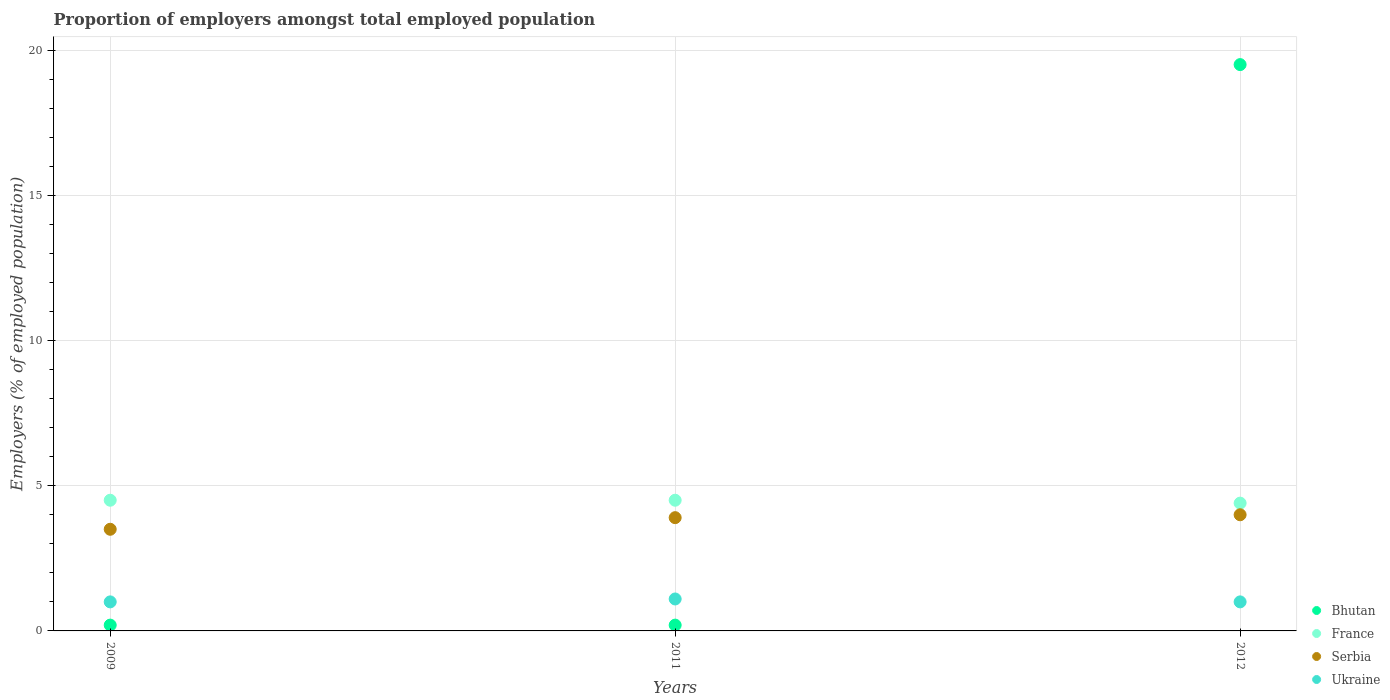How many different coloured dotlines are there?
Your response must be concise. 4. Is the number of dotlines equal to the number of legend labels?
Offer a very short reply. Yes. What is the proportion of employers in Bhutan in 2011?
Offer a very short reply. 0.2. Across all years, what is the maximum proportion of employers in Ukraine?
Ensure brevity in your answer.  1.1. Across all years, what is the minimum proportion of employers in Serbia?
Give a very brief answer. 3.5. In which year was the proportion of employers in Bhutan maximum?
Your answer should be very brief. 2012. In which year was the proportion of employers in Bhutan minimum?
Keep it short and to the point. 2009. What is the total proportion of employers in Bhutan in the graph?
Your answer should be compact. 19.9. What is the difference between the proportion of employers in Serbia in 2009 and that in 2011?
Give a very brief answer. -0.4. What is the difference between the proportion of employers in Ukraine in 2011 and the proportion of employers in Bhutan in 2009?
Keep it short and to the point. 0.9. What is the average proportion of employers in France per year?
Keep it short and to the point. 4.47. In how many years, is the proportion of employers in Bhutan greater than 17 %?
Your answer should be very brief. 1. What is the ratio of the proportion of employers in Bhutan in 2009 to that in 2012?
Provide a short and direct response. 0.01. Is the proportion of employers in Bhutan in 2009 less than that in 2011?
Give a very brief answer. No. Is the difference between the proportion of employers in Bhutan in 2009 and 2011 greater than the difference between the proportion of employers in Serbia in 2009 and 2011?
Give a very brief answer. Yes. What is the difference between the highest and the second highest proportion of employers in Ukraine?
Ensure brevity in your answer.  0.1. What is the difference between the highest and the lowest proportion of employers in France?
Your answer should be very brief. 0.1. Is the sum of the proportion of employers in France in 2009 and 2012 greater than the maximum proportion of employers in Ukraine across all years?
Offer a very short reply. Yes. Is it the case that in every year, the sum of the proportion of employers in Serbia and proportion of employers in France  is greater than the proportion of employers in Ukraine?
Make the answer very short. Yes. Is the proportion of employers in France strictly greater than the proportion of employers in Ukraine over the years?
Keep it short and to the point. Yes. How many years are there in the graph?
Your answer should be compact. 3. Are the values on the major ticks of Y-axis written in scientific E-notation?
Your answer should be very brief. No. Does the graph contain any zero values?
Make the answer very short. No. Does the graph contain grids?
Your answer should be very brief. Yes. What is the title of the graph?
Ensure brevity in your answer.  Proportion of employers amongst total employed population. Does "Algeria" appear as one of the legend labels in the graph?
Provide a short and direct response. No. What is the label or title of the Y-axis?
Provide a succinct answer. Employers (% of employed population). What is the Employers (% of employed population) in Bhutan in 2009?
Your response must be concise. 0.2. What is the Employers (% of employed population) of Ukraine in 2009?
Give a very brief answer. 1. What is the Employers (% of employed population) of Bhutan in 2011?
Provide a short and direct response. 0.2. What is the Employers (% of employed population) of France in 2011?
Provide a short and direct response. 4.5. What is the Employers (% of employed population) of Serbia in 2011?
Make the answer very short. 3.9. What is the Employers (% of employed population) in Ukraine in 2011?
Ensure brevity in your answer.  1.1. What is the Employers (% of employed population) of Bhutan in 2012?
Provide a short and direct response. 19.5. What is the Employers (% of employed population) of France in 2012?
Ensure brevity in your answer.  4.4. What is the Employers (% of employed population) in Ukraine in 2012?
Your response must be concise. 1. Across all years, what is the maximum Employers (% of employed population) in Serbia?
Your answer should be compact. 4. Across all years, what is the maximum Employers (% of employed population) in Ukraine?
Your answer should be very brief. 1.1. Across all years, what is the minimum Employers (% of employed population) of Bhutan?
Give a very brief answer. 0.2. Across all years, what is the minimum Employers (% of employed population) in France?
Make the answer very short. 4.4. Across all years, what is the minimum Employers (% of employed population) of Serbia?
Provide a succinct answer. 3.5. What is the total Employers (% of employed population) of Bhutan in the graph?
Make the answer very short. 19.9. What is the difference between the Employers (% of employed population) of Bhutan in 2009 and that in 2011?
Keep it short and to the point. 0. What is the difference between the Employers (% of employed population) in Bhutan in 2009 and that in 2012?
Provide a short and direct response. -19.3. What is the difference between the Employers (% of employed population) of Ukraine in 2009 and that in 2012?
Your response must be concise. 0. What is the difference between the Employers (% of employed population) in Bhutan in 2011 and that in 2012?
Make the answer very short. -19.3. What is the difference between the Employers (% of employed population) in Serbia in 2011 and that in 2012?
Provide a short and direct response. -0.1. What is the difference between the Employers (% of employed population) in Ukraine in 2011 and that in 2012?
Your answer should be compact. 0.1. What is the difference between the Employers (% of employed population) of Bhutan in 2009 and the Employers (% of employed population) of France in 2011?
Your answer should be compact. -4.3. What is the difference between the Employers (% of employed population) of Bhutan in 2009 and the Employers (% of employed population) of Serbia in 2012?
Your answer should be compact. -3.8. What is the difference between the Employers (% of employed population) of Bhutan in 2011 and the Employers (% of employed population) of Serbia in 2012?
Your answer should be compact. -3.8. What is the difference between the Employers (% of employed population) in Bhutan in 2011 and the Employers (% of employed population) in Ukraine in 2012?
Offer a very short reply. -0.8. What is the difference between the Employers (% of employed population) in France in 2011 and the Employers (% of employed population) in Serbia in 2012?
Give a very brief answer. 0.5. What is the difference between the Employers (% of employed population) of France in 2011 and the Employers (% of employed population) of Ukraine in 2012?
Your answer should be compact. 3.5. What is the difference between the Employers (% of employed population) of Serbia in 2011 and the Employers (% of employed population) of Ukraine in 2012?
Give a very brief answer. 2.9. What is the average Employers (% of employed population) in Bhutan per year?
Keep it short and to the point. 6.63. What is the average Employers (% of employed population) in France per year?
Keep it short and to the point. 4.47. In the year 2009, what is the difference between the Employers (% of employed population) in Bhutan and Employers (% of employed population) in France?
Provide a short and direct response. -4.3. In the year 2009, what is the difference between the Employers (% of employed population) in Bhutan and Employers (% of employed population) in Serbia?
Offer a very short reply. -3.3. In the year 2009, what is the difference between the Employers (% of employed population) in Bhutan and Employers (% of employed population) in Ukraine?
Keep it short and to the point. -0.8. In the year 2009, what is the difference between the Employers (% of employed population) in France and Employers (% of employed population) in Serbia?
Keep it short and to the point. 1. In the year 2009, what is the difference between the Employers (% of employed population) in France and Employers (% of employed population) in Ukraine?
Your answer should be compact. 3.5. In the year 2011, what is the difference between the Employers (% of employed population) of Bhutan and Employers (% of employed population) of Serbia?
Your response must be concise. -3.7. In the year 2011, what is the difference between the Employers (% of employed population) in France and Employers (% of employed population) in Serbia?
Your answer should be compact. 0.6. In the year 2011, what is the difference between the Employers (% of employed population) of Serbia and Employers (% of employed population) of Ukraine?
Your answer should be compact. 2.8. In the year 2012, what is the difference between the Employers (% of employed population) of Bhutan and Employers (% of employed population) of France?
Make the answer very short. 15.1. In the year 2012, what is the difference between the Employers (% of employed population) of Bhutan and Employers (% of employed population) of Serbia?
Provide a short and direct response. 15.5. In the year 2012, what is the difference between the Employers (% of employed population) of Bhutan and Employers (% of employed population) of Ukraine?
Make the answer very short. 18.5. In the year 2012, what is the difference between the Employers (% of employed population) of France and Employers (% of employed population) of Ukraine?
Your answer should be compact. 3.4. In the year 2012, what is the difference between the Employers (% of employed population) in Serbia and Employers (% of employed population) in Ukraine?
Make the answer very short. 3. What is the ratio of the Employers (% of employed population) of France in 2009 to that in 2011?
Keep it short and to the point. 1. What is the ratio of the Employers (% of employed population) in Serbia in 2009 to that in 2011?
Ensure brevity in your answer.  0.9. What is the ratio of the Employers (% of employed population) in Ukraine in 2009 to that in 2011?
Ensure brevity in your answer.  0.91. What is the ratio of the Employers (% of employed population) in Bhutan in 2009 to that in 2012?
Give a very brief answer. 0.01. What is the ratio of the Employers (% of employed population) of France in 2009 to that in 2012?
Your answer should be compact. 1.02. What is the ratio of the Employers (% of employed population) in Bhutan in 2011 to that in 2012?
Make the answer very short. 0.01. What is the ratio of the Employers (% of employed population) of France in 2011 to that in 2012?
Give a very brief answer. 1.02. What is the difference between the highest and the second highest Employers (% of employed population) in Bhutan?
Your response must be concise. 19.3. What is the difference between the highest and the second highest Employers (% of employed population) of France?
Your answer should be very brief. 0. What is the difference between the highest and the lowest Employers (% of employed population) in Bhutan?
Keep it short and to the point. 19.3. What is the difference between the highest and the lowest Employers (% of employed population) of France?
Ensure brevity in your answer.  0.1. What is the difference between the highest and the lowest Employers (% of employed population) in Serbia?
Give a very brief answer. 0.5. What is the difference between the highest and the lowest Employers (% of employed population) in Ukraine?
Make the answer very short. 0.1. 